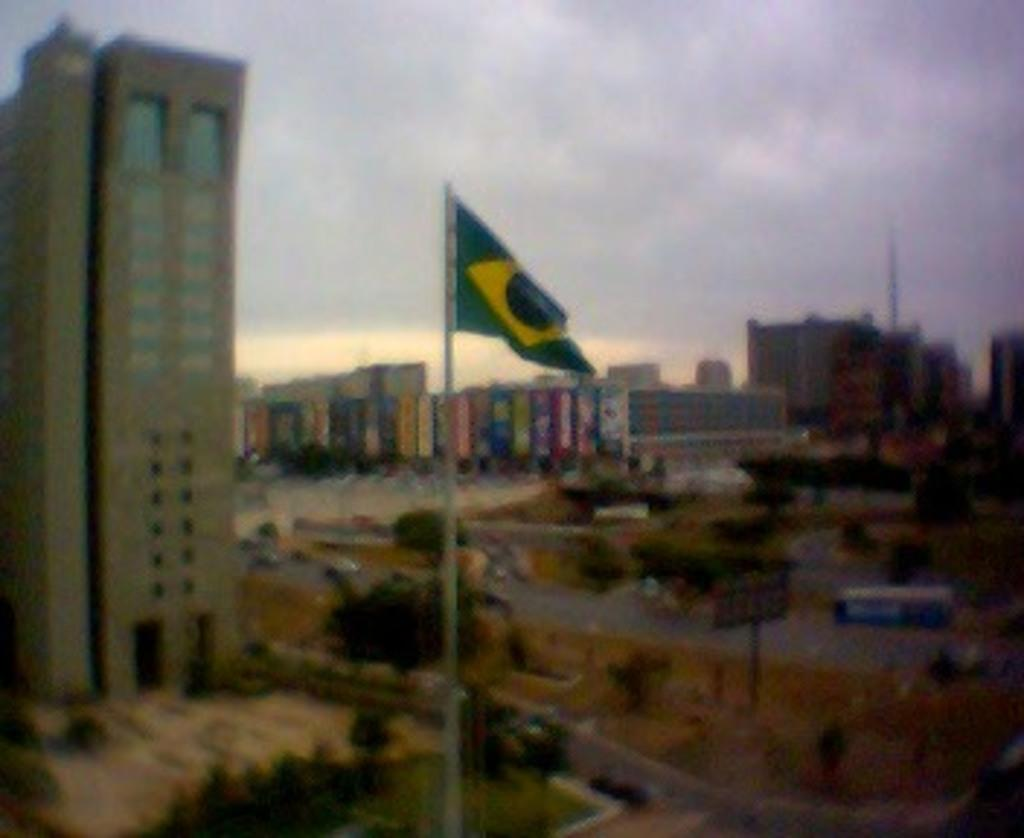What structures can be seen in the image? There are buildings in the image. What type of vegetation is present in the image? There are trees in the image. What objects are supporting something in the image? There are poles in the image. What is located in the center of the image? There is a flag in the center of the image. What part of the natural environment is visible in the image? The sky is visible in the background of the image. What type of transportation is visible in the image? There are vehicles on the road at the bottom of the image. What type of frame is holding the flag in the image? There is no frame holding the flag in the image; the flag is attached to a pole. What type of hose is connected to the vehicles in the image? There is no hose connected to the vehicles in the image; they are simply driving on the road. 